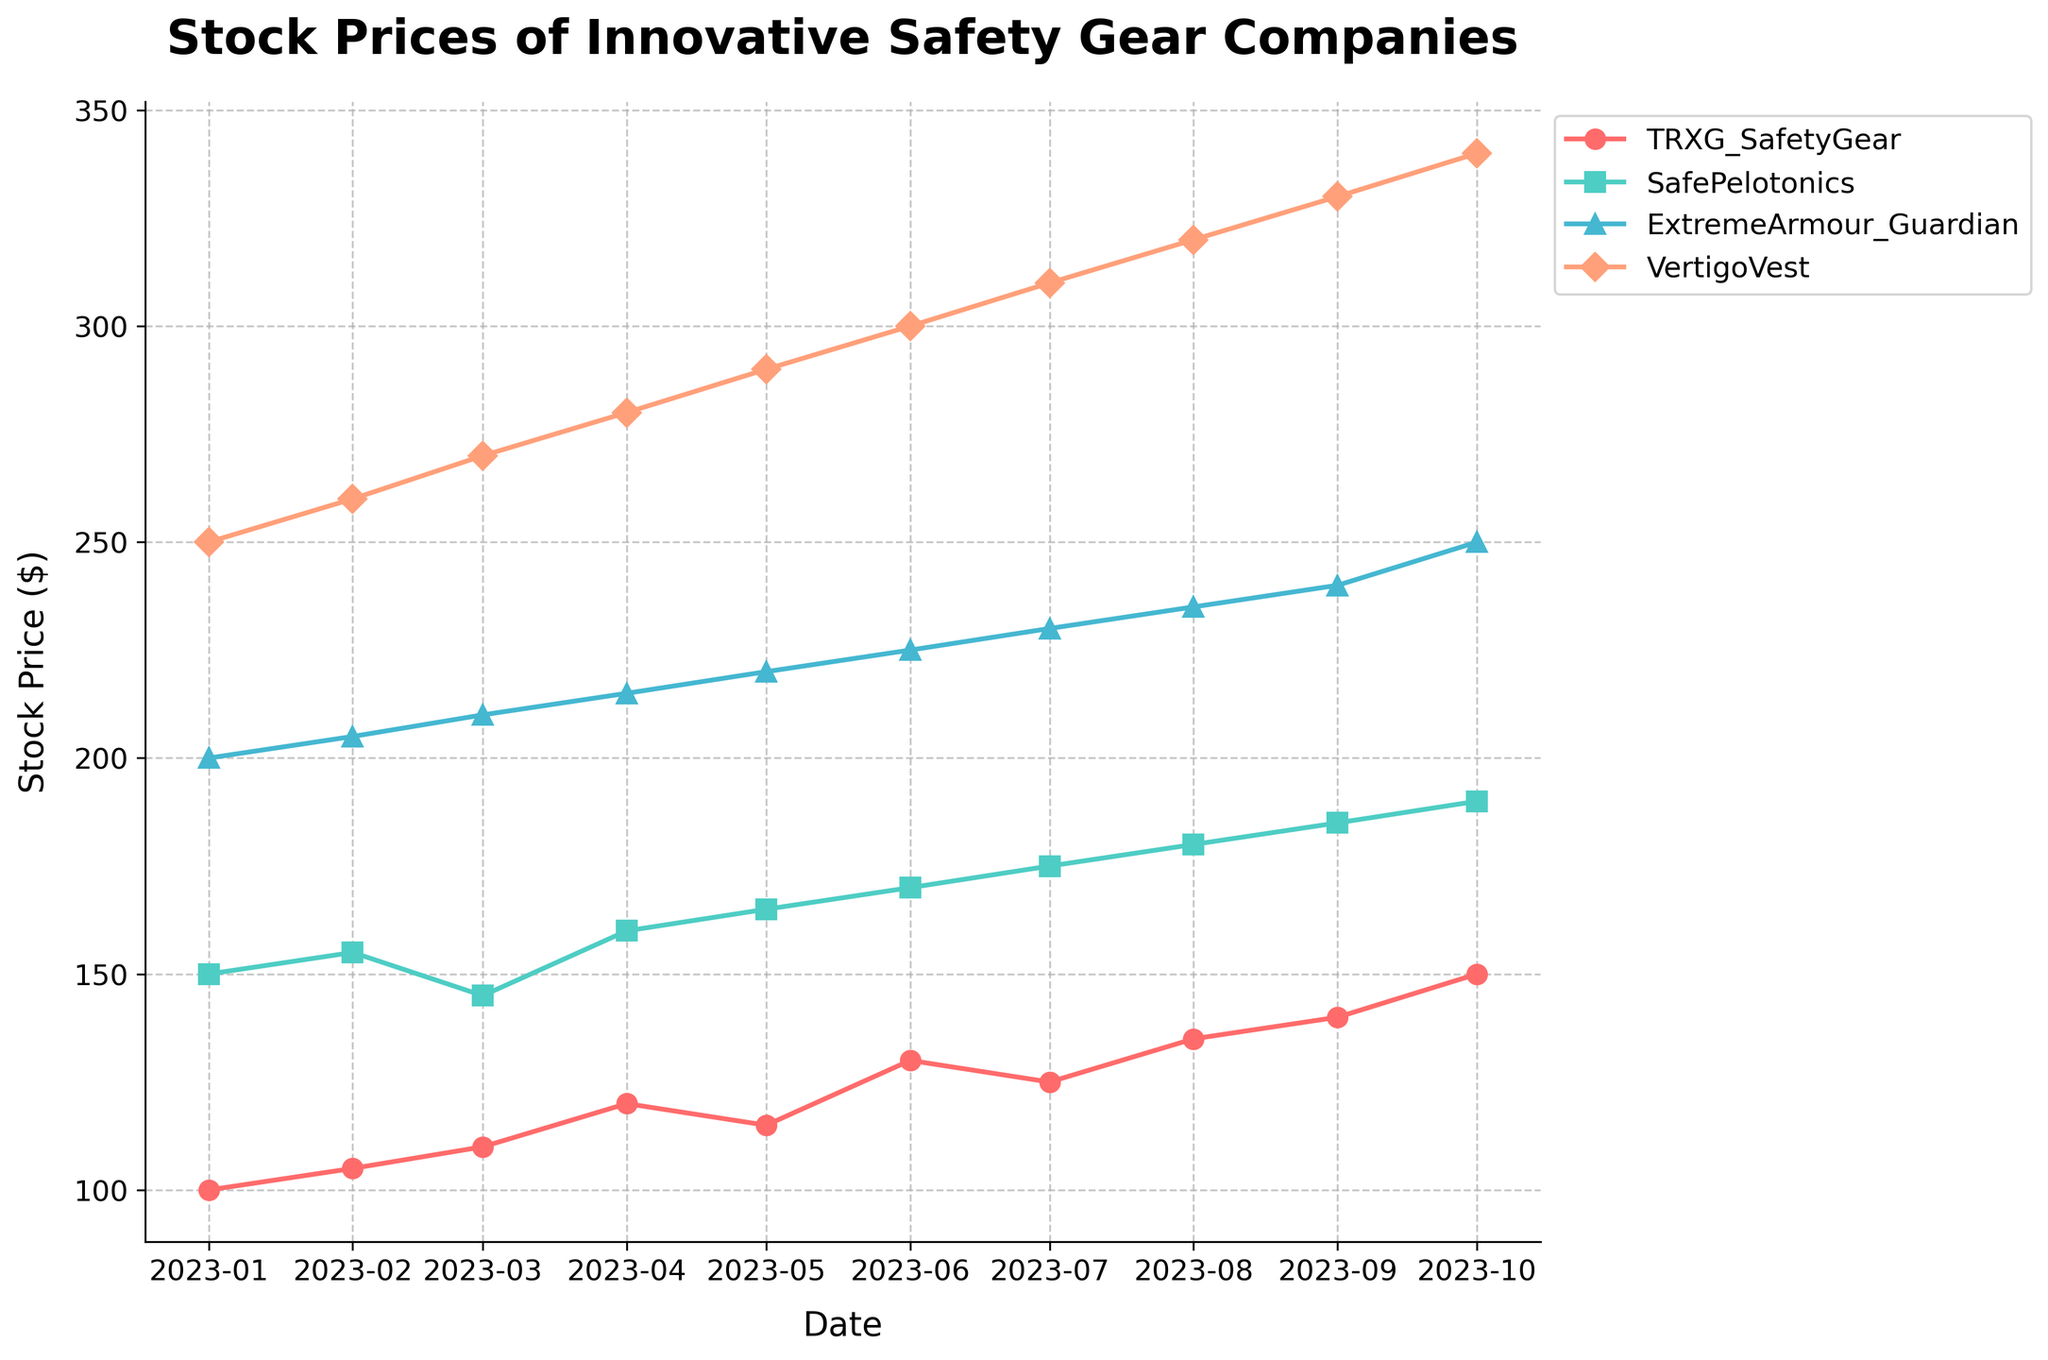How many companies are being compared in the plot? There are four lines in the figure, each representing a different company (TRXG SafetyGear, SafePelotonics, ExtremeArmour Guardian, and VertigoVest).
Answer: 4 Which company had the highest stock price in October 2023? In October 2023, the highest stock price is observed for VertigoVest.
Answer: VertigoVest What is the overall trend of TRXG SafetyGear's stock price from January to October 2023? TRXG SafetyGear's stock price shows a general upward trend from $100 in January 2023 to $150 in October 2023, despite a slight drop in May and July 2023.
Answer: Upward Which month saw SafePelotonics' stock price dip? SafePelotonics' stock price dipped in March 2023, decreasing from $155 in February to $145 in March.
Answer: March By how much did ExtremeArmour Guardian's stock price increase from January to October 2023? ExtremeArmour Guardian's stock price increased from $200 in January 2023 to $250 in October 2023. The increase is calculated as $250 - $200.
Answer: $50 Which company had the most stable stock price trend over the period? SafePelotonics shows the least fluctuation, increasing almost steadily from $150 to $190 over the period.
Answer: SafePelotonics What's the difference in stock price between VertigoVest and TRXG SafetyGear in October 2023? In October 2023, the stock price for VertigoVest is $340, and for TRXG SafetyGear, it is $150. The difference is $340 - $150.
Answer: $190 Which company had the highest monthly growth in any single month? VertigoVest had the highest monthly growth from January to February 2023, increasing by $10 ($260-$250).
Answer: VertigoVest Compared to the start of the observed period, which company showed the greatest total increase in stock price by October 2023? VertigoVest had an initial price of $250 in January 2023 and rose to $340 in October 2023, showing a total increase of $90.
Answer: VertigoVest What month did TRXG SafetyGear's stock price first exceed $130? TRXG SafetyGear's stock price first exceeded $130 in June 2023.
Answer: June 